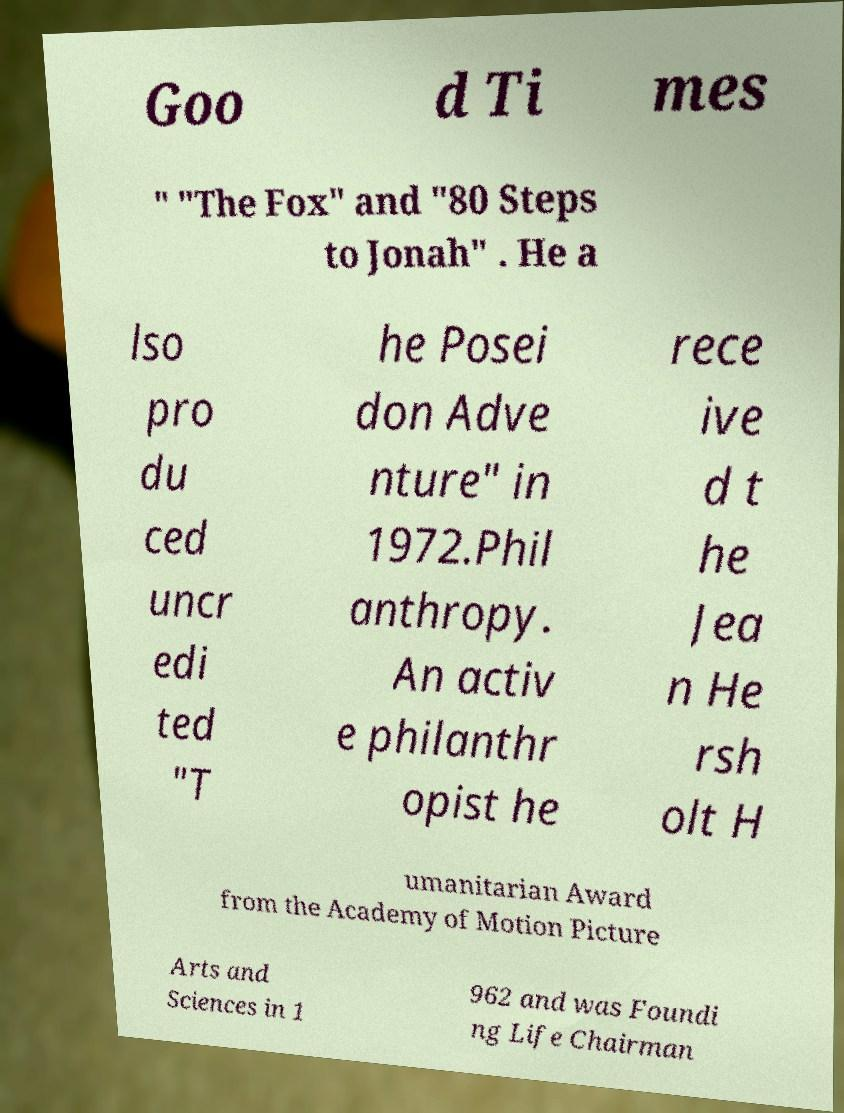Can you read and provide the text displayed in the image?This photo seems to have some interesting text. Can you extract and type it out for me? Goo d Ti mes " "The Fox" and "80 Steps to Jonah" . He a lso pro du ced uncr edi ted "T he Posei don Adve nture" in 1972.Phil anthropy. An activ e philanthr opist he rece ive d t he Jea n He rsh olt H umanitarian Award from the Academy of Motion Picture Arts and Sciences in 1 962 and was Foundi ng Life Chairman 